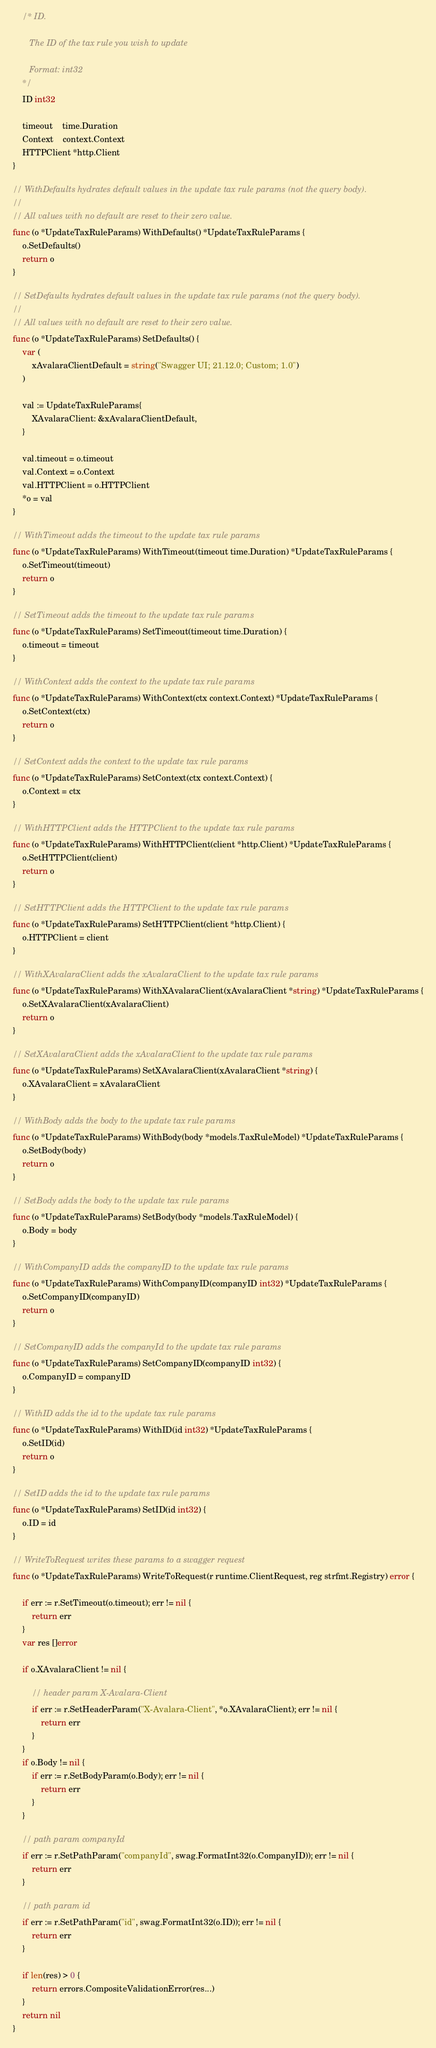<code> <loc_0><loc_0><loc_500><loc_500><_Go_>
	/* ID.

	   The ID of the tax rule you wish to update

	   Format: int32
	*/
	ID int32

	timeout    time.Duration
	Context    context.Context
	HTTPClient *http.Client
}

// WithDefaults hydrates default values in the update tax rule params (not the query body).
//
// All values with no default are reset to their zero value.
func (o *UpdateTaxRuleParams) WithDefaults() *UpdateTaxRuleParams {
	o.SetDefaults()
	return o
}

// SetDefaults hydrates default values in the update tax rule params (not the query body).
//
// All values with no default are reset to their zero value.
func (o *UpdateTaxRuleParams) SetDefaults() {
	var (
		xAvalaraClientDefault = string("Swagger UI; 21.12.0; Custom; 1.0")
	)

	val := UpdateTaxRuleParams{
		XAvalaraClient: &xAvalaraClientDefault,
	}

	val.timeout = o.timeout
	val.Context = o.Context
	val.HTTPClient = o.HTTPClient
	*o = val
}

// WithTimeout adds the timeout to the update tax rule params
func (o *UpdateTaxRuleParams) WithTimeout(timeout time.Duration) *UpdateTaxRuleParams {
	o.SetTimeout(timeout)
	return o
}

// SetTimeout adds the timeout to the update tax rule params
func (o *UpdateTaxRuleParams) SetTimeout(timeout time.Duration) {
	o.timeout = timeout
}

// WithContext adds the context to the update tax rule params
func (o *UpdateTaxRuleParams) WithContext(ctx context.Context) *UpdateTaxRuleParams {
	o.SetContext(ctx)
	return o
}

// SetContext adds the context to the update tax rule params
func (o *UpdateTaxRuleParams) SetContext(ctx context.Context) {
	o.Context = ctx
}

// WithHTTPClient adds the HTTPClient to the update tax rule params
func (o *UpdateTaxRuleParams) WithHTTPClient(client *http.Client) *UpdateTaxRuleParams {
	o.SetHTTPClient(client)
	return o
}

// SetHTTPClient adds the HTTPClient to the update tax rule params
func (o *UpdateTaxRuleParams) SetHTTPClient(client *http.Client) {
	o.HTTPClient = client
}

// WithXAvalaraClient adds the xAvalaraClient to the update tax rule params
func (o *UpdateTaxRuleParams) WithXAvalaraClient(xAvalaraClient *string) *UpdateTaxRuleParams {
	o.SetXAvalaraClient(xAvalaraClient)
	return o
}

// SetXAvalaraClient adds the xAvalaraClient to the update tax rule params
func (o *UpdateTaxRuleParams) SetXAvalaraClient(xAvalaraClient *string) {
	o.XAvalaraClient = xAvalaraClient
}

// WithBody adds the body to the update tax rule params
func (o *UpdateTaxRuleParams) WithBody(body *models.TaxRuleModel) *UpdateTaxRuleParams {
	o.SetBody(body)
	return o
}

// SetBody adds the body to the update tax rule params
func (o *UpdateTaxRuleParams) SetBody(body *models.TaxRuleModel) {
	o.Body = body
}

// WithCompanyID adds the companyID to the update tax rule params
func (o *UpdateTaxRuleParams) WithCompanyID(companyID int32) *UpdateTaxRuleParams {
	o.SetCompanyID(companyID)
	return o
}

// SetCompanyID adds the companyId to the update tax rule params
func (o *UpdateTaxRuleParams) SetCompanyID(companyID int32) {
	o.CompanyID = companyID
}

// WithID adds the id to the update tax rule params
func (o *UpdateTaxRuleParams) WithID(id int32) *UpdateTaxRuleParams {
	o.SetID(id)
	return o
}

// SetID adds the id to the update tax rule params
func (o *UpdateTaxRuleParams) SetID(id int32) {
	o.ID = id
}

// WriteToRequest writes these params to a swagger request
func (o *UpdateTaxRuleParams) WriteToRequest(r runtime.ClientRequest, reg strfmt.Registry) error {

	if err := r.SetTimeout(o.timeout); err != nil {
		return err
	}
	var res []error

	if o.XAvalaraClient != nil {

		// header param X-Avalara-Client
		if err := r.SetHeaderParam("X-Avalara-Client", *o.XAvalaraClient); err != nil {
			return err
		}
	}
	if o.Body != nil {
		if err := r.SetBodyParam(o.Body); err != nil {
			return err
		}
	}

	// path param companyId
	if err := r.SetPathParam("companyId", swag.FormatInt32(o.CompanyID)); err != nil {
		return err
	}

	// path param id
	if err := r.SetPathParam("id", swag.FormatInt32(o.ID)); err != nil {
		return err
	}

	if len(res) > 0 {
		return errors.CompositeValidationError(res...)
	}
	return nil
}
</code> 